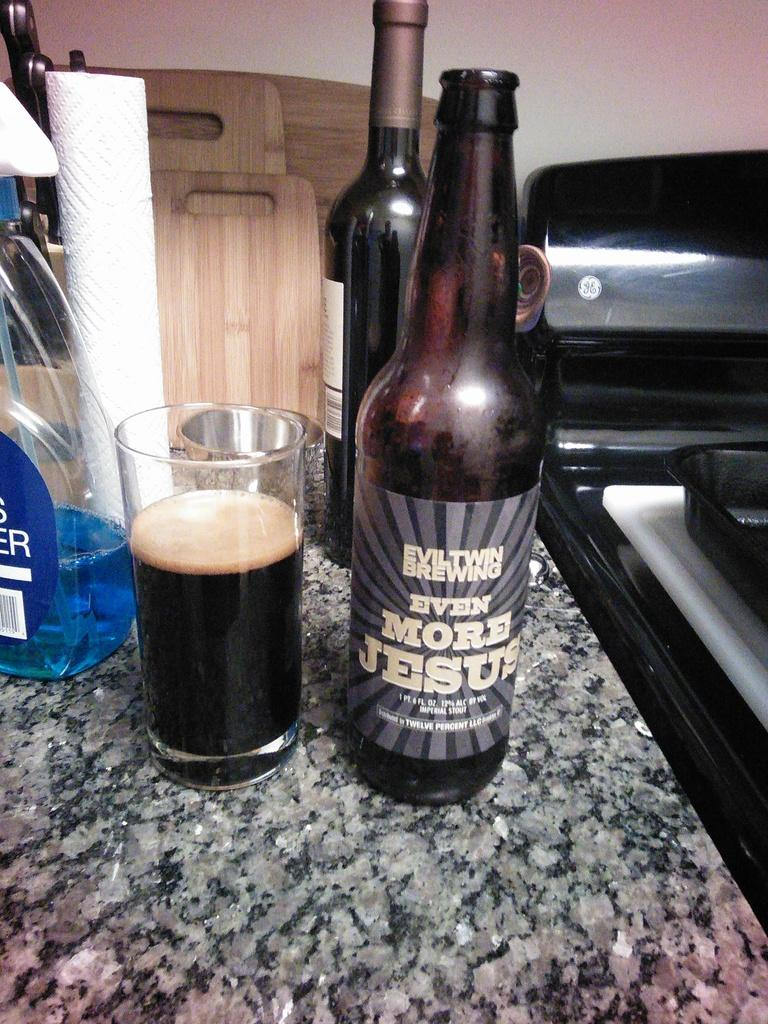<image>
Give a short and clear explanation of the subsequent image. A bottle of stout beer by Evil Twin Brewing has been poured into a glass that is sitting next to a bottle of blue glass cleaner. 